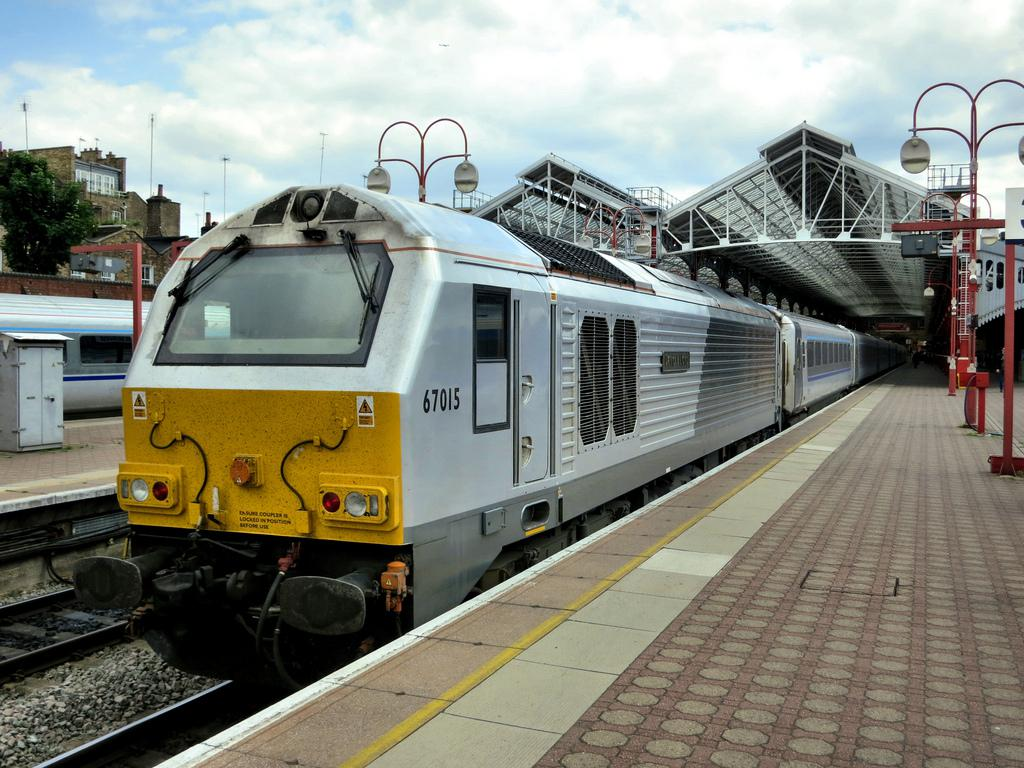Question: what color is the train?
Choices:
A. Blue.
B. Yellow and white.
C. Black.
D. Orange.
Answer with the letter. Answer: B Question: what is the weather like?
Choices:
A. It's rainy.
B. It's hot.
C. It's sunny.
D. It's cold.
Answer with the letter. Answer: C Question: where is the train?
Choices:
A. On the tracks.
B. At the station.
C. In the tunnel.
D. At the platform.
Answer with the letter. Answer: D Question: what color are the lamp posts?
Choices:
A. Red.
B. Black.
C. White.
D. Green.
Answer with the letter. Answer: A Question: where are the clouds?
Choices:
A. On T.V.
B. In the sky.
C. In the picture.
D. Behind the plane.
Answer with the letter. Answer: B Question: what color is the side of the train?
Choices:
A. White.
B. Red.
C. Black.
D. Silver.
Answer with the letter. Answer: D Question: where are the train tracks?
Choices:
A. In the middle of town.
B. By the hardware store.
C. Under the train.
D. Through the mountain.
Answer with the letter. Answer: C Question: what is in the background?
Choices:
A. Signs.
B. Three trains.
C. Second train.
D. Train tracks.
Answer with the letter. Answer: C Question: what else is in the background?
Choices:
A. Buildings.
B. Trees.
C. People.
D. Signs.
Answer with the letter. Answer: A Question: who is standing on the platform?
Choices:
A. Two people.
B. No one.
C. Four people.
D. One person.
Answer with the letter. Answer: B Question: what is at the platform?
Choices:
A. Tourists.
B. Engineer.
C. Tour guides.
D. Train.
Answer with the letter. Answer: D Question: what are there several of?
Choices:
A. Green posts.
B. Blue posts.
C. Red posts.
D. Black posts.
Answer with the letter. Answer: C Question: where was this photo taken?
Choices:
A. Library.
B. On the sidewalk.
C. Hospital.
D. Nursing home.
Answer with the letter. Answer: B Question: what is on the front of the train?
Choices:
A. Cow catcher.
B. Steel.
C. A whistle.
D. A big window.
Answer with the letter. Answer: D Question: what direction are the lamposts?
Choices:
A. Straight up.
B. Bent to the left.
C. Bent to the right.
D. Curved downward.
Answer with the letter. Answer: D 